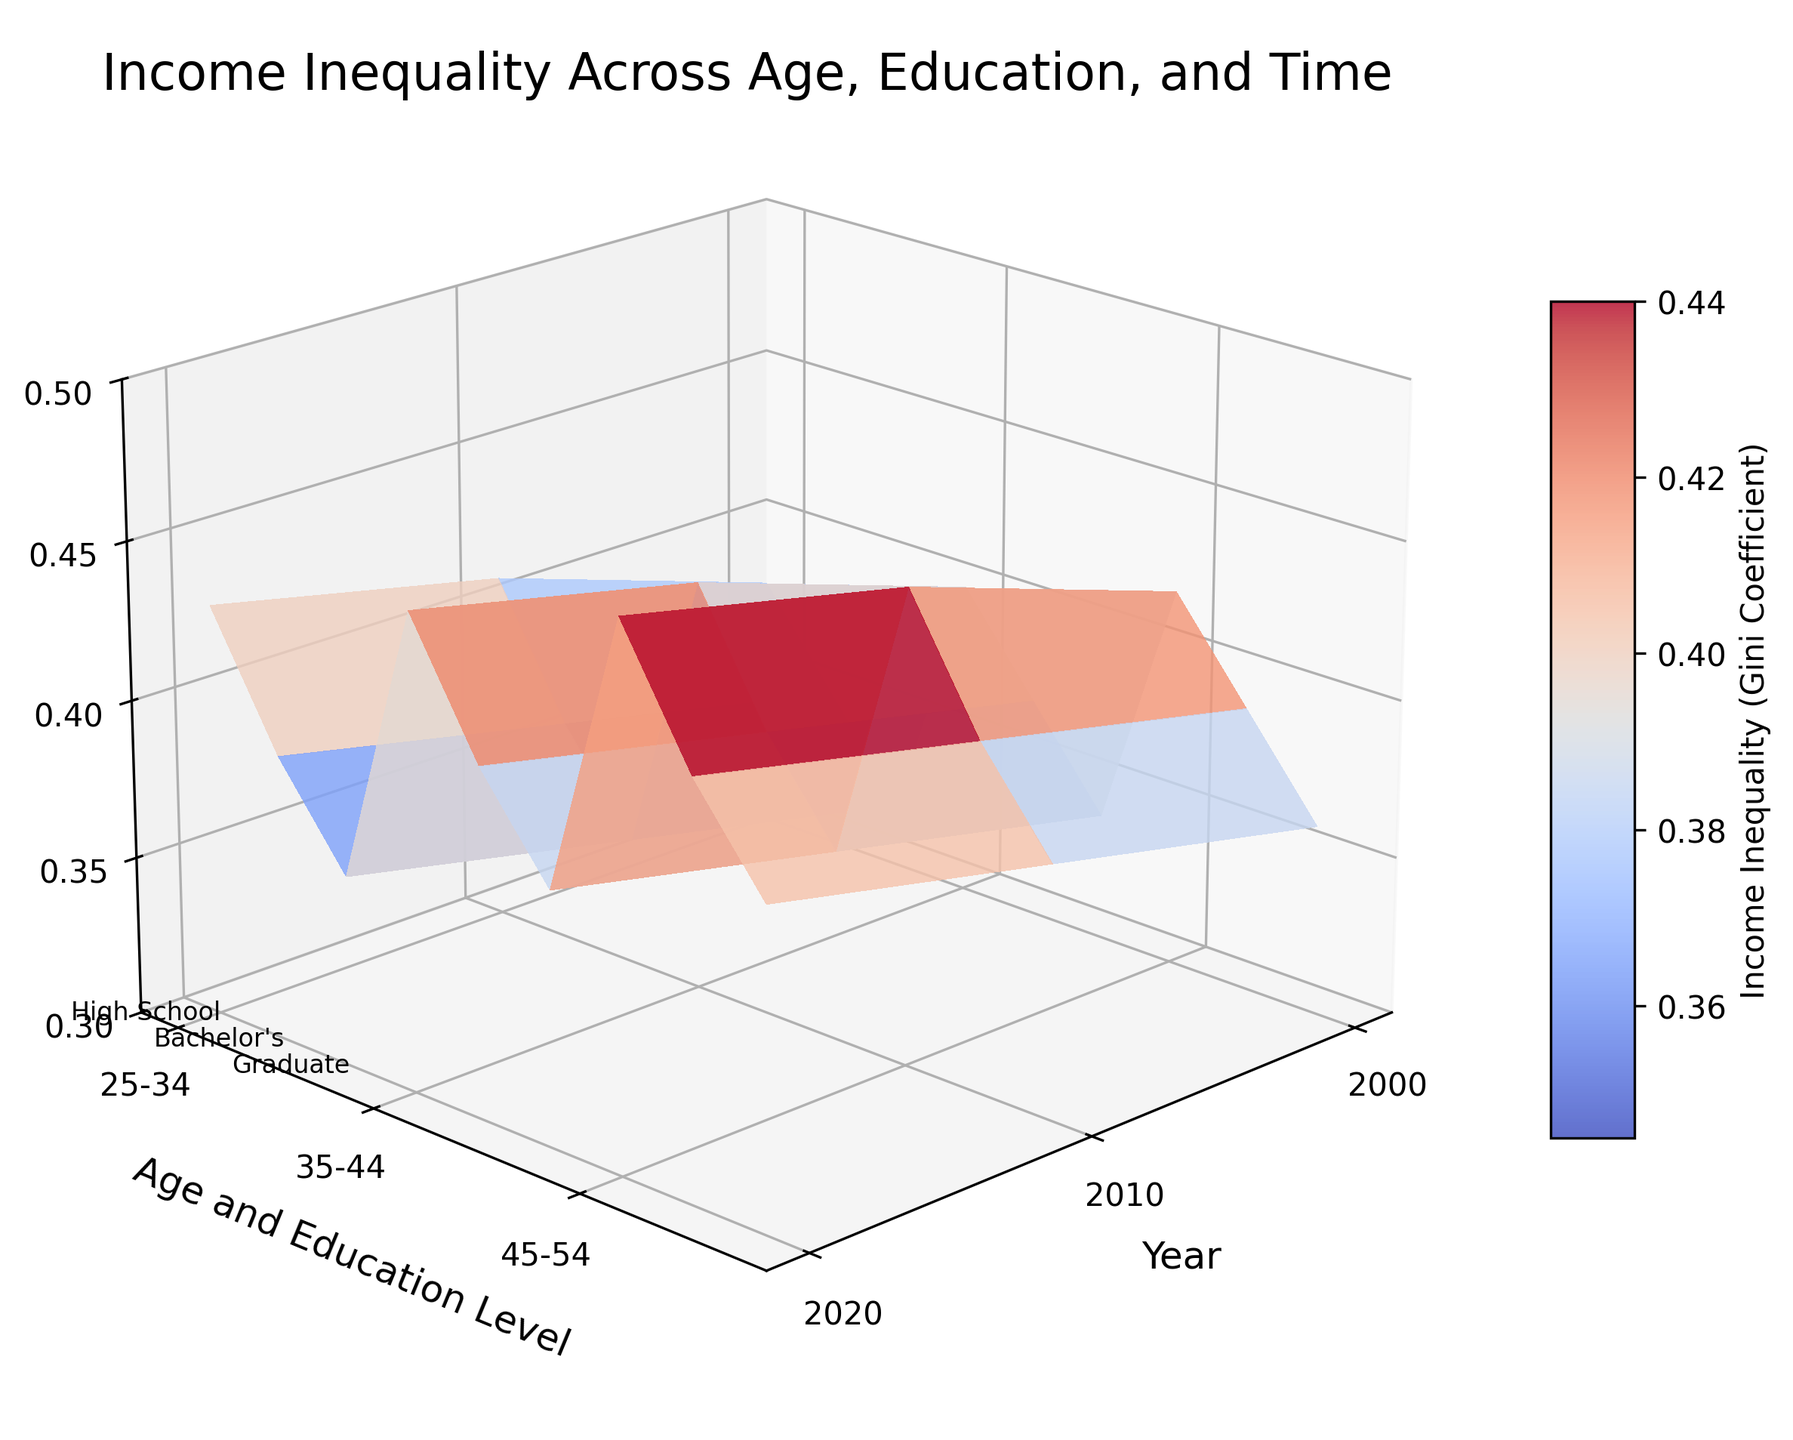What is the title of the 3D surface plot? The title is typically written at the top of the plot and aims to provide a quick summary of what the plot is about. Here, the title is "Income Inequality Across Age, Education, and Time." This informs the viewer of the content displayed.
Answer: Income Inequality Across Age, Education, and Time What does the z-axis represent in the plot? The z-axis, often positioned vertically, indicates the dependent variable in a 3D plot. Here, the label on the z-axis shows that it represents "Income Inequality (Gini Coefficient)."
Answer: Income Inequality (Gini Coefficient) How does income inequality change for the 25-34 age group with a High School education level from 2000 to 2020? By examining the 3D surface plot and following the data points along the z-axis for the 25-34 age group with High School education from the year 2000 to 2020, we can see an increase. Specifically, the Gini Coefficient rises from 0.38 in 2000 to 0.43 in 2020.
Answer: It increases Which education level consistently shows the lowest income inequality across all age groups and time periods? To determine this, look for which education level has the lowest z-values (Income Inequality/Gini Coefficients) across all age groups and years. The Graduate education level consistently has the lowest Gini Coefficients compared to High School and Bachelor's education levels.
Answer: Graduate For the 45-54 age group, in which year did High School education show the highest level of income inequality? Locate the points for the 45-54 age group with High School education on the plot and identify the peak Gini Coefficient along the z-axis. The highest coefficient for this group appears in the year 2020 at 0.47.
Answer: 2020 Compare the change in income inequality from 2000 to 2020 between the Bachelor's and Graduate education levels for the 35-44 age group. For this comparison, identify the z-values (Gini Coefficients) for Bachelor's and Graduate levels in 2000 and 2020 for the 35-44 age group. For Bachelor's, it changes from 0.37 to 0.41 (an increase of 0.04). For Graduate, it changes from 0.34 to 0.38 (an increase of 0.04). Both have the same increase of 0.04.
Answer: Same increase Which age group has the least increase in income inequality for High School education from 2000 to 2020? Calculate the difference in Gini Coefficient for each age group with High School education from 2000 to 2020. The 25-34 age group goes from 0.38 to 0.43 (increase of 0.05), the 35-44 group goes from 0.40 to 0.45 (increase of 0.05), and the 45-54 group goes from 0.42 to 0.47 (increase of 0.05). Since all age groups show the same increase of 0.05, there isn’t a group with a lesser increase.
Answer: None (same increase) What color represents lower levels of income inequality in the plot? Colors are often used to represent different ranges of the dependent variable. In this plot, the color map (coolwarm) usually displays cooler colors (like blue) for lower values and warmer colors (like red) for higher values. Thus, blue shades represent lower levels of income inequality.
Answer: Blue Which year shows the most significant overall increase in income inequality across all age and education groups? This requires a comparative look at each age and education subgroup over time. Observe average increases from one year to the next for each group, and calculate the summed increase for all groups. From the plotted data, 2010 to 2020 shows more noticeable increases across various groups.
Answer: 2010 to 2020 